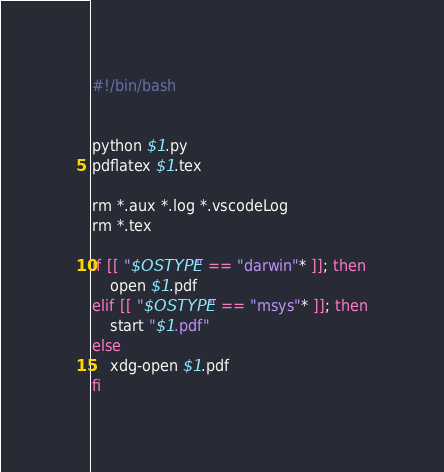Convert code to text. <code><loc_0><loc_0><loc_500><loc_500><_Bash_>#!/bin/bash


python $1.py 
pdflatex $1.tex

rm *.aux *.log *.vscodeLog
rm *.tex

if [[ "$OSTYPE" == "darwin"* ]]; then
    open $1.pdf
elif [[ "$OSTYPE" == "msys"* ]]; then
    start "$1.pdf"
else
    xdg-open $1.pdf
fi
</code> 